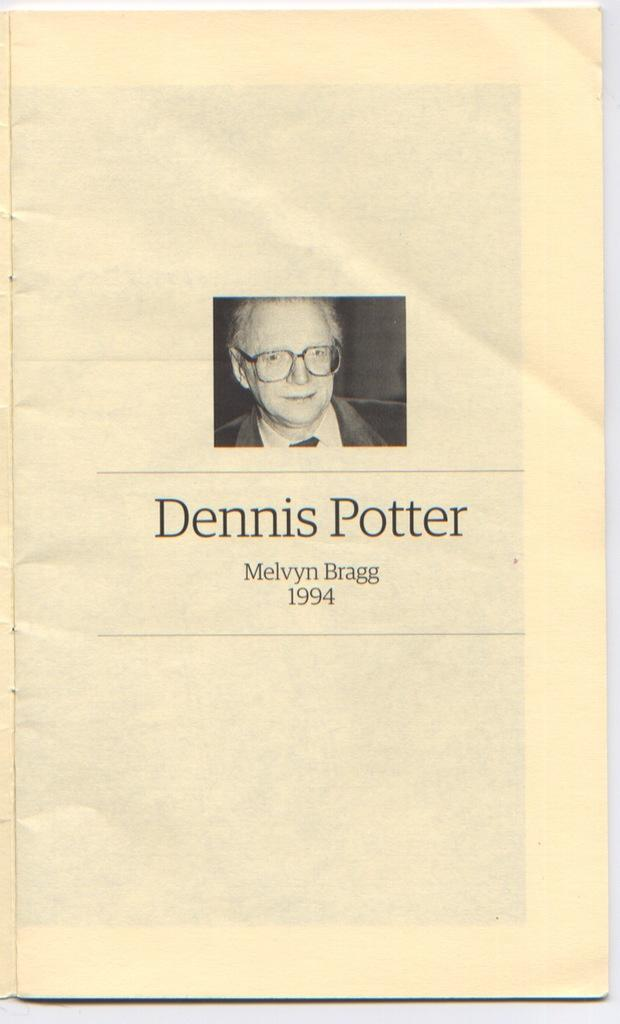What is the main subject of the poster in the image? The poster features a person wearing spectacles. Are there any other elements on the poster besides the person? Yes, there are words written on the poster. Can you recall any memories of the person on the poster taking a flight? There is no information about the person on the poster or any flights in the image, so it's not possible to recall any memories related to that. 